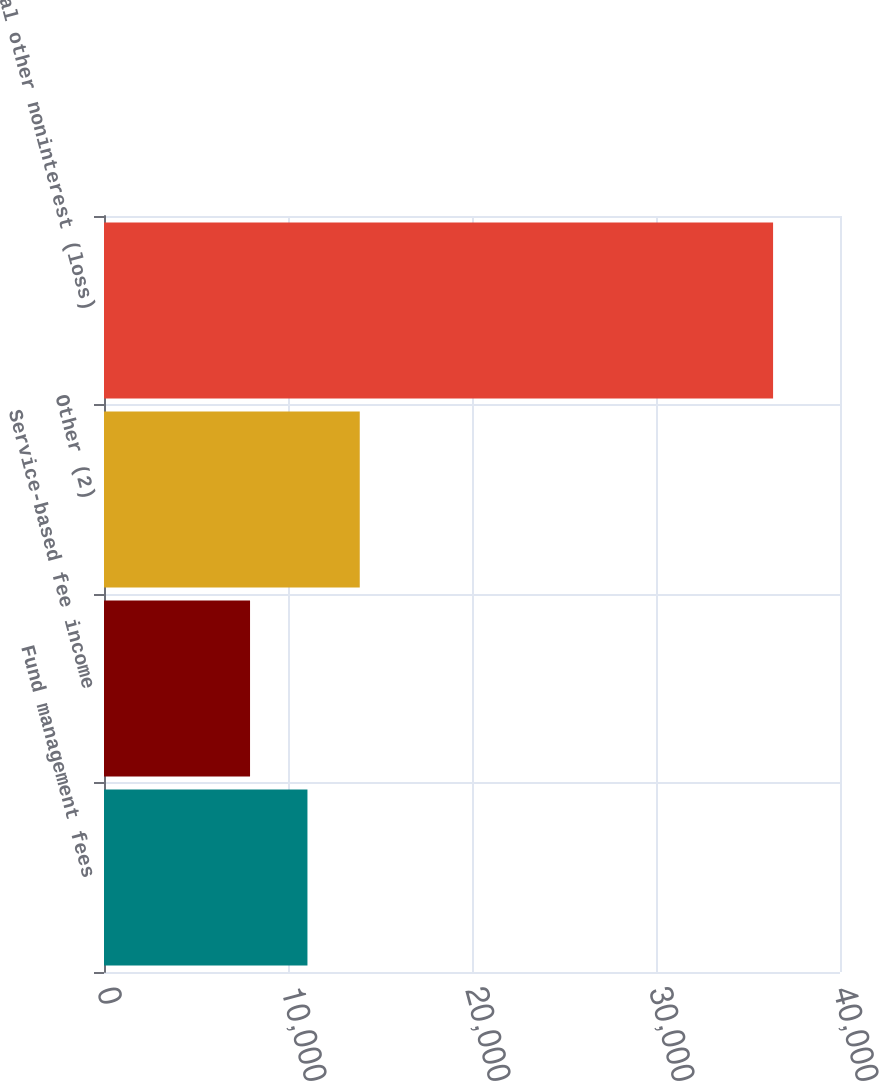<chart> <loc_0><loc_0><loc_500><loc_500><bar_chart><fcel>Fund management fees<fcel>Service-based fee income<fcel>Other (2)<fcel>Total other noninterest (loss)<nl><fcel>11057<fcel>7937<fcel>13899.6<fcel>36363<nl></chart> 